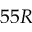<formula> <loc_0><loc_0><loc_500><loc_500>5 5 R</formula> 